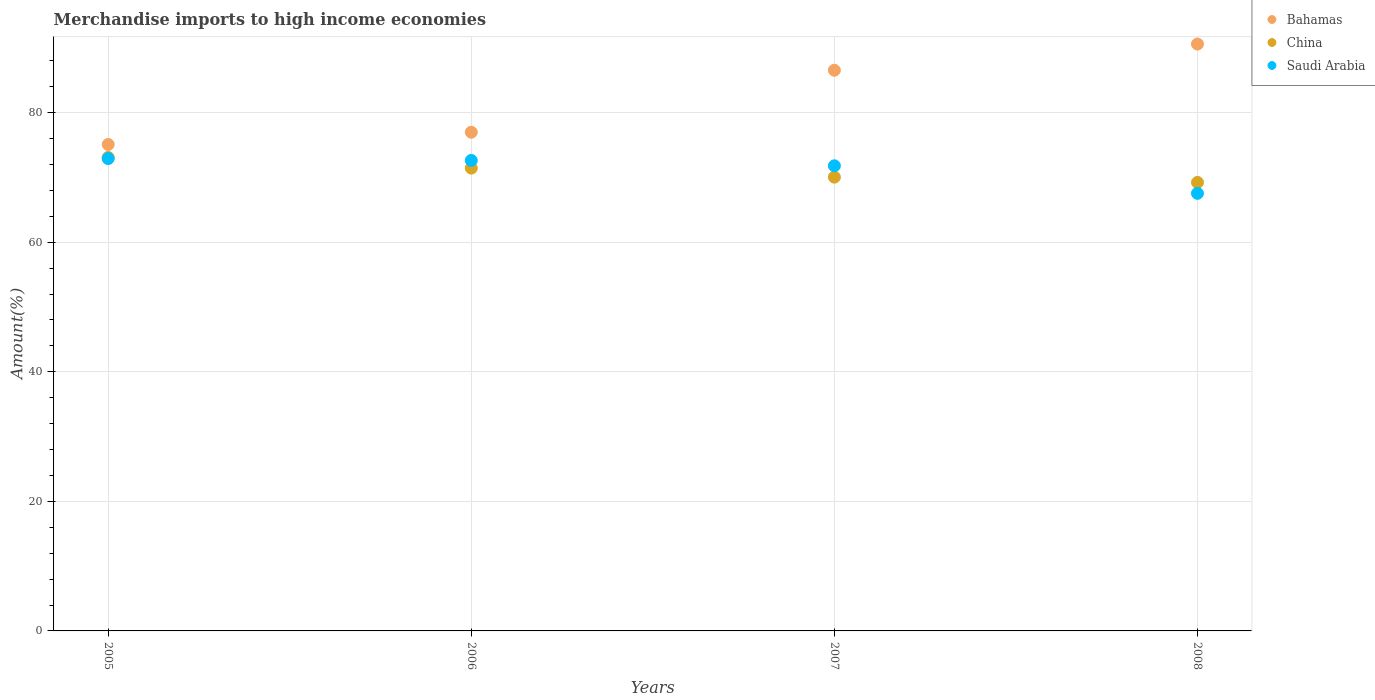What is the percentage of amount earned from merchandise imports in Saudi Arabia in 2005?
Offer a very short reply. 72.91. Across all years, what is the maximum percentage of amount earned from merchandise imports in China?
Offer a terse response. 73.09. Across all years, what is the minimum percentage of amount earned from merchandise imports in Bahamas?
Your answer should be compact. 75.09. What is the total percentage of amount earned from merchandise imports in Bahamas in the graph?
Offer a terse response. 329.22. What is the difference between the percentage of amount earned from merchandise imports in China in 2006 and that in 2007?
Your answer should be very brief. 1.39. What is the difference between the percentage of amount earned from merchandise imports in Saudi Arabia in 2007 and the percentage of amount earned from merchandise imports in Bahamas in 2008?
Give a very brief answer. -18.8. What is the average percentage of amount earned from merchandise imports in Saudi Arabia per year?
Offer a terse response. 71.22. In the year 2006, what is the difference between the percentage of amount earned from merchandise imports in Saudi Arabia and percentage of amount earned from merchandise imports in China?
Offer a very short reply. 1.19. What is the ratio of the percentage of amount earned from merchandise imports in Bahamas in 2005 to that in 2006?
Keep it short and to the point. 0.98. What is the difference between the highest and the second highest percentage of amount earned from merchandise imports in Bahamas?
Offer a very short reply. 4.05. What is the difference between the highest and the lowest percentage of amount earned from merchandise imports in Bahamas?
Keep it short and to the point. 15.5. Is the sum of the percentage of amount earned from merchandise imports in Saudi Arabia in 2005 and 2007 greater than the maximum percentage of amount earned from merchandise imports in Bahamas across all years?
Ensure brevity in your answer.  Yes. Is the percentage of amount earned from merchandise imports in Saudi Arabia strictly greater than the percentage of amount earned from merchandise imports in China over the years?
Your answer should be compact. No. How many dotlines are there?
Your answer should be very brief. 3. How many years are there in the graph?
Provide a short and direct response. 4. What is the difference between two consecutive major ticks on the Y-axis?
Your answer should be very brief. 20. What is the title of the graph?
Ensure brevity in your answer.  Merchandise imports to high income economies. Does "Central African Republic" appear as one of the legend labels in the graph?
Make the answer very short. No. What is the label or title of the X-axis?
Ensure brevity in your answer.  Years. What is the label or title of the Y-axis?
Offer a very short reply. Amount(%). What is the Amount(%) of Bahamas in 2005?
Keep it short and to the point. 75.09. What is the Amount(%) of China in 2005?
Ensure brevity in your answer.  73.09. What is the Amount(%) of Saudi Arabia in 2005?
Offer a terse response. 72.91. What is the Amount(%) of Bahamas in 2006?
Your response must be concise. 76.98. What is the Amount(%) of China in 2006?
Your answer should be compact. 71.44. What is the Amount(%) in Saudi Arabia in 2006?
Keep it short and to the point. 72.63. What is the Amount(%) of Bahamas in 2007?
Ensure brevity in your answer.  86.55. What is the Amount(%) in China in 2007?
Provide a short and direct response. 70.05. What is the Amount(%) in Saudi Arabia in 2007?
Ensure brevity in your answer.  71.8. What is the Amount(%) in Bahamas in 2008?
Provide a short and direct response. 90.6. What is the Amount(%) of China in 2008?
Your answer should be compact. 69.24. What is the Amount(%) in Saudi Arabia in 2008?
Provide a short and direct response. 67.55. Across all years, what is the maximum Amount(%) of Bahamas?
Ensure brevity in your answer.  90.6. Across all years, what is the maximum Amount(%) in China?
Keep it short and to the point. 73.09. Across all years, what is the maximum Amount(%) in Saudi Arabia?
Keep it short and to the point. 72.91. Across all years, what is the minimum Amount(%) in Bahamas?
Make the answer very short. 75.09. Across all years, what is the minimum Amount(%) in China?
Keep it short and to the point. 69.24. Across all years, what is the minimum Amount(%) of Saudi Arabia?
Offer a very short reply. 67.55. What is the total Amount(%) in Bahamas in the graph?
Your answer should be very brief. 329.22. What is the total Amount(%) in China in the graph?
Offer a terse response. 283.81. What is the total Amount(%) of Saudi Arabia in the graph?
Keep it short and to the point. 284.89. What is the difference between the Amount(%) in Bahamas in 2005 and that in 2006?
Give a very brief answer. -1.89. What is the difference between the Amount(%) of China in 2005 and that in 2006?
Provide a short and direct response. 1.64. What is the difference between the Amount(%) of Saudi Arabia in 2005 and that in 2006?
Offer a very short reply. 0.28. What is the difference between the Amount(%) in Bahamas in 2005 and that in 2007?
Offer a terse response. -11.46. What is the difference between the Amount(%) of China in 2005 and that in 2007?
Give a very brief answer. 3.03. What is the difference between the Amount(%) of Saudi Arabia in 2005 and that in 2007?
Keep it short and to the point. 1.11. What is the difference between the Amount(%) of Bahamas in 2005 and that in 2008?
Your answer should be very brief. -15.5. What is the difference between the Amount(%) in China in 2005 and that in 2008?
Your answer should be compact. 3.85. What is the difference between the Amount(%) of Saudi Arabia in 2005 and that in 2008?
Ensure brevity in your answer.  5.36. What is the difference between the Amount(%) in Bahamas in 2006 and that in 2007?
Ensure brevity in your answer.  -9.57. What is the difference between the Amount(%) of China in 2006 and that in 2007?
Ensure brevity in your answer.  1.39. What is the difference between the Amount(%) in Saudi Arabia in 2006 and that in 2007?
Your answer should be very brief. 0.83. What is the difference between the Amount(%) of Bahamas in 2006 and that in 2008?
Give a very brief answer. -13.61. What is the difference between the Amount(%) in China in 2006 and that in 2008?
Keep it short and to the point. 2.2. What is the difference between the Amount(%) of Saudi Arabia in 2006 and that in 2008?
Your answer should be very brief. 5.08. What is the difference between the Amount(%) of Bahamas in 2007 and that in 2008?
Make the answer very short. -4.05. What is the difference between the Amount(%) of China in 2007 and that in 2008?
Keep it short and to the point. 0.81. What is the difference between the Amount(%) in Saudi Arabia in 2007 and that in 2008?
Ensure brevity in your answer.  4.25. What is the difference between the Amount(%) of Bahamas in 2005 and the Amount(%) of China in 2006?
Keep it short and to the point. 3.65. What is the difference between the Amount(%) of Bahamas in 2005 and the Amount(%) of Saudi Arabia in 2006?
Keep it short and to the point. 2.46. What is the difference between the Amount(%) of China in 2005 and the Amount(%) of Saudi Arabia in 2006?
Your answer should be compact. 0.45. What is the difference between the Amount(%) in Bahamas in 2005 and the Amount(%) in China in 2007?
Offer a very short reply. 5.04. What is the difference between the Amount(%) of Bahamas in 2005 and the Amount(%) of Saudi Arabia in 2007?
Provide a succinct answer. 3.29. What is the difference between the Amount(%) in China in 2005 and the Amount(%) in Saudi Arabia in 2007?
Ensure brevity in your answer.  1.28. What is the difference between the Amount(%) of Bahamas in 2005 and the Amount(%) of China in 2008?
Your answer should be very brief. 5.85. What is the difference between the Amount(%) of Bahamas in 2005 and the Amount(%) of Saudi Arabia in 2008?
Ensure brevity in your answer.  7.54. What is the difference between the Amount(%) of China in 2005 and the Amount(%) of Saudi Arabia in 2008?
Provide a short and direct response. 5.54. What is the difference between the Amount(%) of Bahamas in 2006 and the Amount(%) of China in 2007?
Offer a very short reply. 6.93. What is the difference between the Amount(%) of Bahamas in 2006 and the Amount(%) of Saudi Arabia in 2007?
Your answer should be very brief. 5.18. What is the difference between the Amount(%) of China in 2006 and the Amount(%) of Saudi Arabia in 2007?
Provide a short and direct response. -0.36. What is the difference between the Amount(%) of Bahamas in 2006 and the Amount(%) of China in 2008?
Offer a terse response. 7.74. What is the difference between the Amount(%) of Bahamas in 2006 and the Amount(%) of Saudi Arabia in 2008?
Keep it short and to the point. 9.43. What is the difference between the Amount(%) of China in 2006 and the Amount(%) of Saudi Arabia in 2008?
Make the answer very short. 3.89. What is the difference between the Amount(%) in Bahamas in 2007 and the Amount(%) in China in 2008?
Provide a short and direct response. 17.31. What is the difference between the Amount(%) of Bahamas in 2007 and the Amount(%) of Saudi Arabia in 2008?
Make the answer very short. 19. What is the difference between the Amount(%) in China in 2007 and the Amount(%) in Saudi Arabia in 2008?
Your answer should be very brief. 2.5. What is the average Amount(%) of Bahamas per year?
Provide a short and direct response. 82.3. What is the average Amount(%) in China per year?
Your response must be concise. 70.95. What is the average Amount(%) of Saudi Arabia per year?
Your answer should be very brief. 71.22. In the year 2005, what is the difference between the Amount(%) of Bahamas and Amount(%) of China?
Give a very brief answer. 2.01. In the year 2005, what is the difference between the Amount(%) in Bahamas and Amount(%) in Saudi Arabia?
Ensure brevity in your answer.  2.18. In the year 2005, what is the difference between the Amount(%) of China and Amount(%) of Saudi Arabia?
Your answer should be compact. 0.17. In the year 2006, what is the difference between the Amount(%) of Bahamas and Amount(%) of China?
Make the answer very short. 5.54. In the year 2006, what is the difference between the Amount(%) in Bahamas and Amount(%) in Saudi Arabia?
Your answer should be very brief. 4.35. In the year 2006, what is the difference between the Amount(%) in China and Amount(%) in Saudi Arabia?
Offer a terse response. -1.19. In the year 2007, what is the difference between the Amount(%) of Bahamas and Amount(%) of China?
Offer a terse response. 16.5. In the year 2007, what is the difference between the Amount(%) of Bahamas and Amount(%) of Saudi Arabia?
Offer a terse response. 14.75. In the year 2007, what is the difference between the Amount(%) of China and Amount(%) of Saudi Arabia?
Make the answer very short. -1.75. In the year 2008, what is the difference between the Amount(%) in Bahamas and Amount(%) in China?
Offer a very short reply. 21.36. In the year 2008, what is the difference between the Amount(%) in Bahamas and Amount(%) in Saudi Arabia?
Offer a very short reply. 23.05. In the year 2008, what is the difference between the Amount(%) in China and Amount(%) in Saudi Arabia?
Make the answer very short. 1.69. What is the ratio of the Amount(%) in Bahamas in 2005 to that in 2006?
Make the answer very short. 0.98. What is the ratio of the Amount(%) of Bahamas in 2005 to that in 2007?
Provide a short and direct response. 0.87. What is the ratio of the Amount(%) of China in 2005 to that in 2007?
Give a very brief answer. 1.04. What is the ratio of the Amount(%) of Saudi Arabia in 2005 to that in 2007?
Ensure brevity in your answer.  1.02. What is the ratio of the Amount(%) in Bahamas in 2005 to that in 2008?
Make the answer very short. 0.83. What is the ratio of the Amount(%) of China in 2005 to that in 2008?
Offer a terse response. 1.06. What is the ratio of the Amount(%) in Saudi Arabia in 2005 to that in 2008?
Give a very brief answer. 1.08. What is the ratio of the Amount(%) in Bahamas in 2006 to that in 2007?
Your response must be concise. 0.89. What is the ratio of the Amount(%) of China in 2006 to that in 2007?
Your response must be concise. 1.02. What is the ratio of the Amount(%) in Saudi Arabia in 2006 to that in 2007?
Make the answer very short. 1.01. What is the ratio of the Amount(%) of Bahamas in 2006 to that in 2008?
Offer a terse response. 0.85. What is the ratio of the Amount(%) of China in 2006 to that in 2008?
Your answer should be compact. 1.03. What is the ratio of the Amount(%) of Saudi Arabia in 2006 to that in 2008?
Offer a terse response. 1.08. What is the ratio of the Amount(%) in Bahamas in 2007 to that in 2008?
Your answer should be compact. 0.96. What is the ratio of the Amount(%) in China in 2007 to that in 2008?
Provide a succinct answer. 1.01. What is the ratio of the Amount(%) in Saudi Arabia in 2007 to that in 2008?
Provide a short and direct response. 1.06. What is the difference between the highest and the second highest Amount(%) in Bahamas?
Keep it short and to the point. 4.05. What is the difference between the highest and the second highest Amount(%) in China?
Give a very brief answer. 1.64. What is the difference between the highest and the second highest Amount(%) in Saudi Arabia?
Your answer should be very brief. 0.28. What is the difference between the highest and the lowest Amount(%) in Bahamas?
Provide a succinct answer. 15.5. What is the difference between the highest and the lowest Amount(%) in China?
Your answer should be compact. 3.85. What is the difference between the highest and the lowest Amount(%) in Saudi Arabia?
Keep it short and to the point. 5.36. 